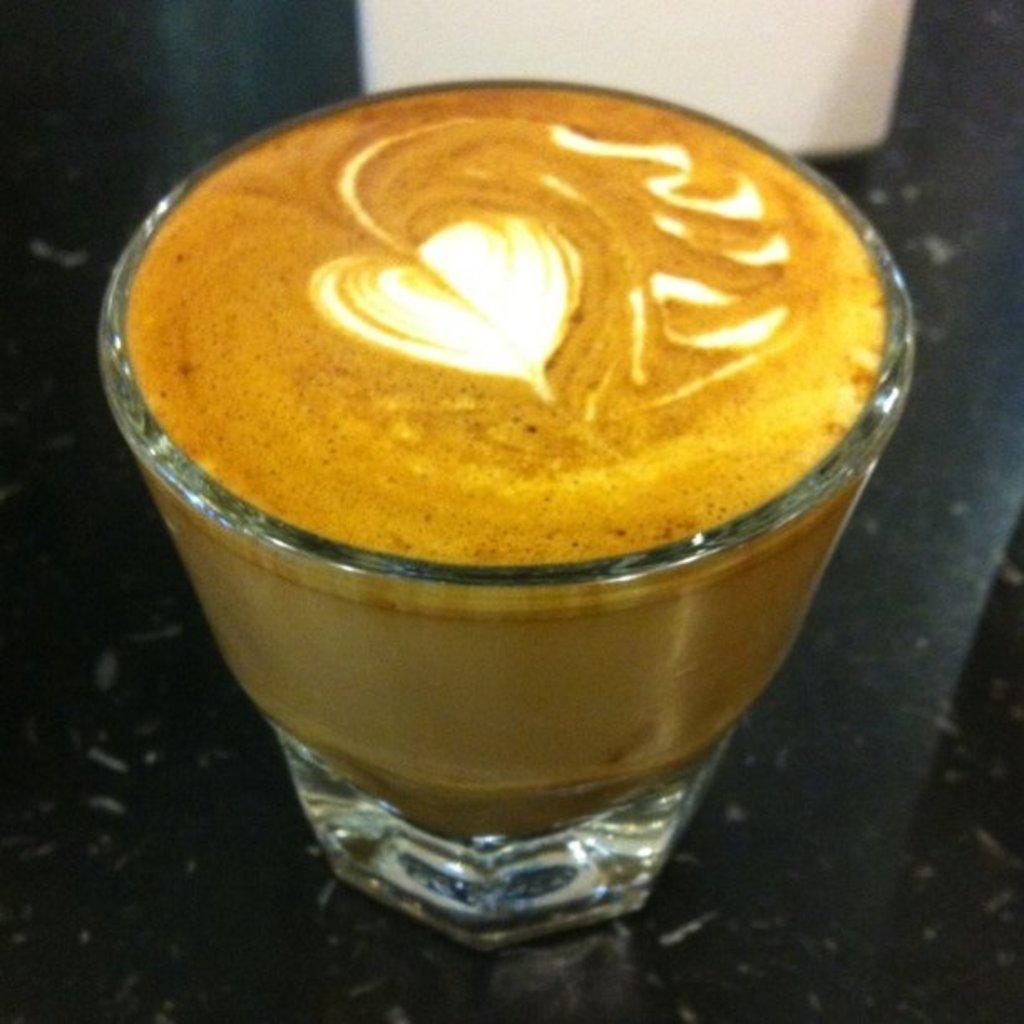Could you give a brief overview of what you see in this image? In the image we can see there is a coffee in the glass and heart shape is made with cream. 